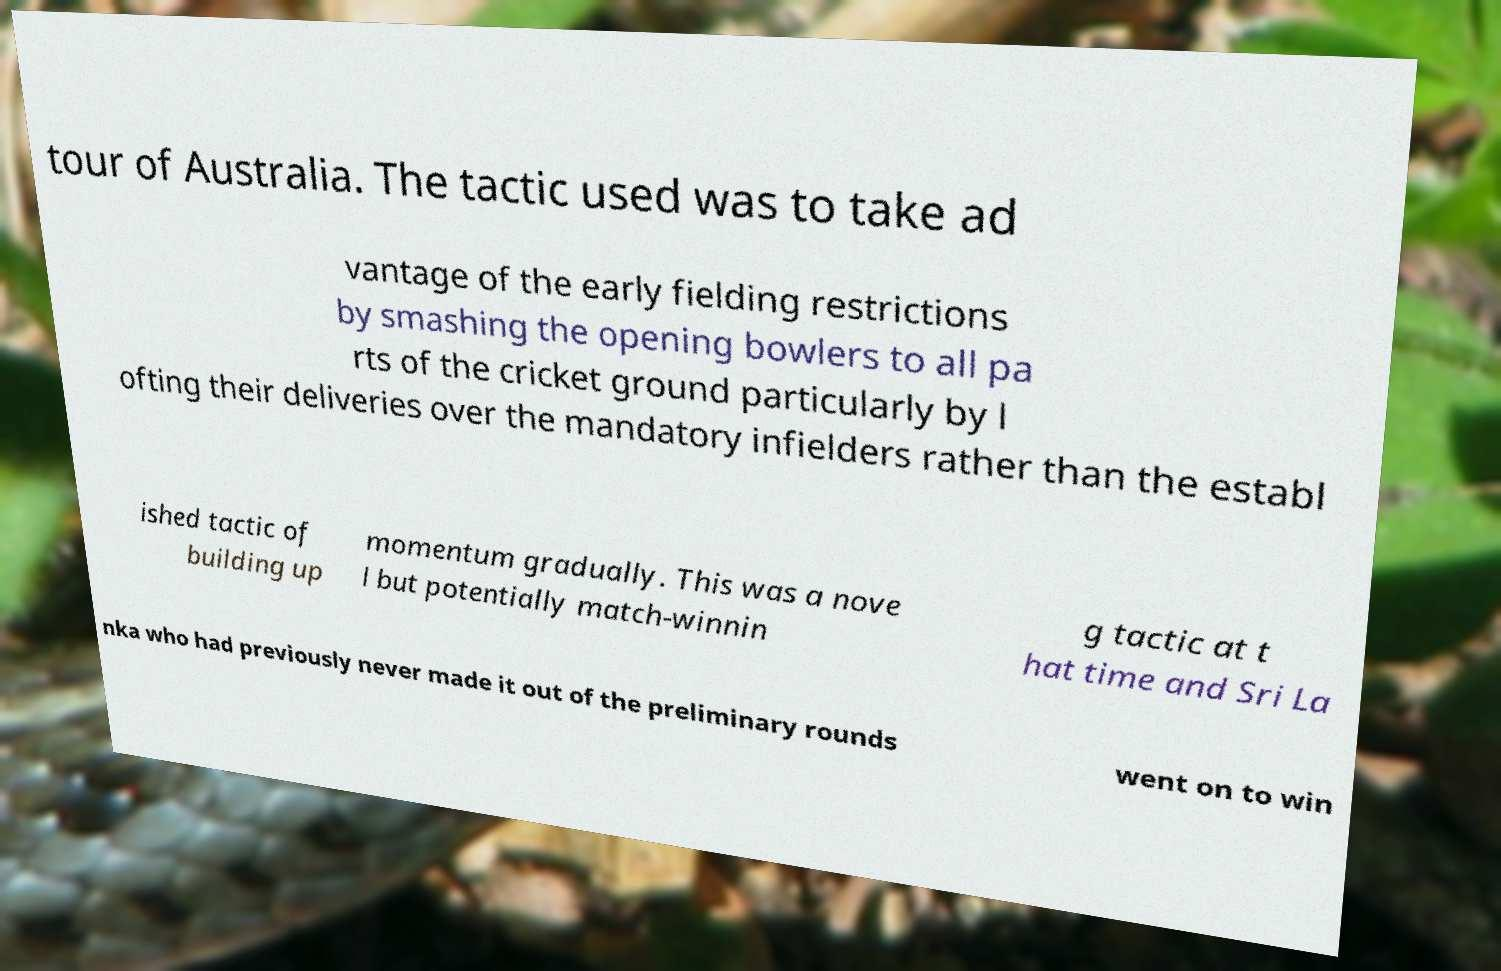What messages or text are displayed in this image? I need them in a readable, typed format. tour of Australia. The tactic used was to take ad vantage of the early fielding restrictions by smashing the opening bowlers to all pa rts of the cricket ground particularly by l ofting their deliveries over the mandatory infielders rather than the establ ished tactic of building up momentum gradually. This was a nove l but potentially match-winnin g tactic at t hat time and Sri La nka who had previously never made it out of the preliminary rounds went on to win 